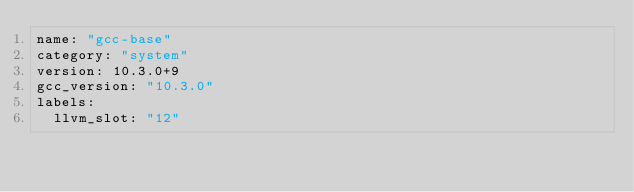Convert code to text. <code><loc_0><loc_0><loc_500><loc_500><_YAML_>name: "gcc-base"
category: "system"
version: 10.3.0+9
gcc_version: "10.3.0"
labels:
  llvm_slot: "12"
</code> 